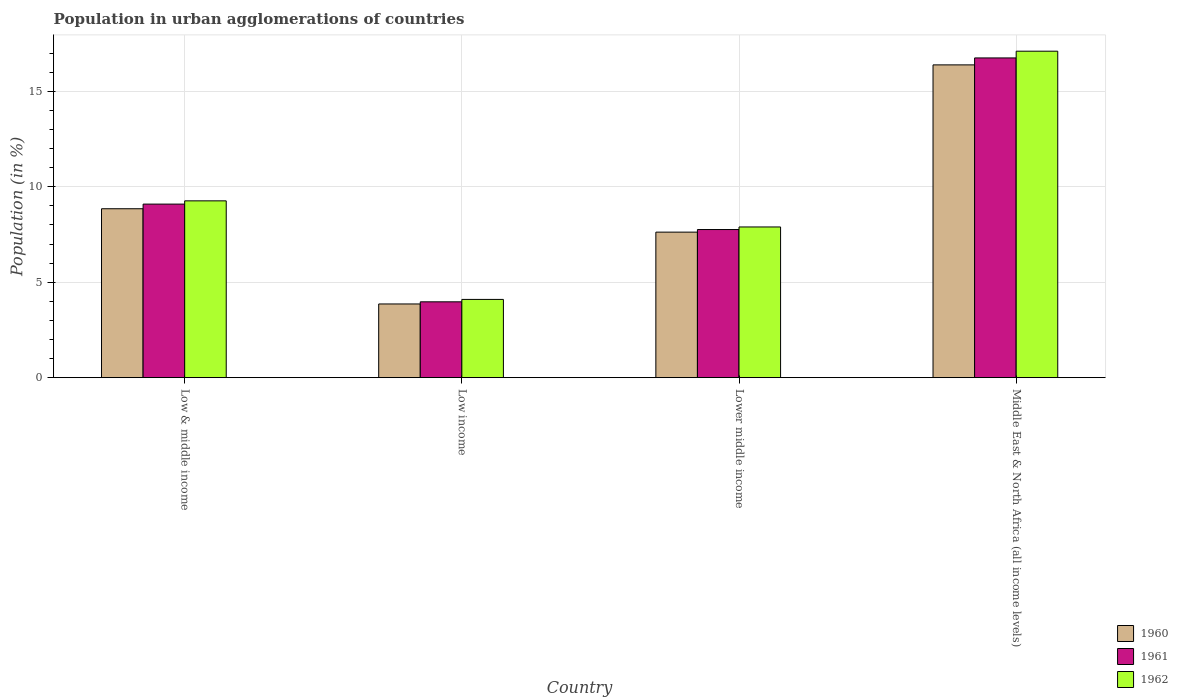How many groups of bars are there?
Your answer should be compact. 4. Are the number of bars on each tick of the X-axis equal?
Make the answer very short. Yes. How many bars are there on the 4th tick from the right?
Your answer should be very brief. 3. What is the label of the 1st group of bars from the left?
Give a very brief answer. Low & middle income. What is the percentage of population in urban agglomerations in 1961 in Low & middle income?
Your response must be concise. 9.09. Across all countries, what is the maximum percentage of population in urban agglomerations in 1960?
Ensure brevity in your answer.  16.39. Across all countries, what is the minimum percentage of population in urban agglomerations in 1960?
Ensure brevity in your answer.  3.86. In which country was the percentage of population in urban agglomerations in 1961 maximum?
Your answer should be very brief. Middle East & North Africa (all income levels). What is the total percentage of population in urban agglomerations in 1961 in the graph?
Your answer should be compact. 37.58. What is the difference between the percentage of population in urban agglomerations in 1961 in Low income and that in Lower middle income?
Your answer should be compact. -3.79. What is the difference between the percentage of population in urban agglomerations in 1962 in Lower middle income and the percentage of population in urban agglomerations in 1961 in Low income?
Make the answer very short. 3.92. What is the average percentage of population in urban agglomerations in 1962 per country?
Make the answer very short. 9.59. What is the difference between the percentage of population in urban agglomerations of/in 1960 and percentage of population in urban agglomerations of/in 1961 in Low income?
Provide a short and direct response. -0.11. In how many countries, is the percentage of population in urban agglomerations in 1962 greater than 16 %?
Offer a very short reply. 1. What is the ratio of the percentage of population in urban agglomerations in 1960 in Low & middle income to that in Lower middle income?
Offer a very short reply. 1.16. Is the percentage of population in urban agglomerations in 1961 in Low income less than that in Lower middle income?
Provide a succinct answer. Yes. What is the difference between the highest and the second highest percentage of population in urban agglomerations in 1962?
Make the answer very short. 7.84. What is the difference between the highest and the lowest percentage of population in urban agglomerations in 1961?
Your answer should be very brief. 12.78. Is the sum of the percentage of population in urban agglomerations in 1961 in Low & middle income and Middle East & North Africa (all income levels) greater than the maximum percentage of population in urban agglomerations in 1962 across all countries?
Keep it short and to the point. Yes. Is it the case that in every country, the sum of the percentage of population in urban agglomerations in 1960 and percentage of population in urban agglomerations in 1962 is greater than the percentage of population in urban agglomerations in 1961?
Ensure brevity in your answer.  Yes. How many bars are there?
Offer a very short reply. 12. Are all the bars in the graph horizontal?
Keep it short and to the point. No. How many countries are there in the graph?
Make the answer very short. 4. What is the difference between two consecutive major ticks on the Y-axis?
Ensure brevity in your answer.  5. Are the values on the major ticks of Y-axis written in scientific E-notation?
Give a very brief answer. No. How are the legend labels stacked?
Ensure brevity in your answer.  Vertical. What is the title of the graph?
Give a very brief answer. Population in urban agglomerations of countries. What is the label or title of the Y-axis?
Offer a very short reply. Population (in %). What is the Population (in %) of 1960 in Low & middle income?
Make the answer very short. 8.85. What is the Population (in %) of 1961 in Low & middle income?
Provide a succinct answer. 9.09. What is the Population (in %) of 1962 in Low & middle income?
Offer a terse response. 9.27. What is the Population (in %) in 1960 in Low income?
Offer a terse response. 3.86. What is the Population (in %) in 1961 in Low income?
Provide a succinct answer. 3.97. What is the Population (in %) in 1962 in Low income?
Make the answer very short. 4.1. What is the Population (in %) in 1960 in Lower middle income?
Offer a terse response. 7.63. What is the Population (in %) in 1961 in Lower middle income?
Keep it short and to the point. 7.76. What is the Population (in %) of 1962 in Lower middle income?
Your answer should be compact. 7.9. What is the Population (in %) in 1960 in Middle East & North Africa (all income levels)?
Your response must be concise. 16.39. What is the Population (in %) in 1961 in Middle East & North Africa (all income levels)?
Offer a terse response. 16.75. What is the Population (in %) in 1962 in Middle East & North Africa (all income levels)?
Your response must be concise. 17.11. Across all countries, what is the maximum Population (in %) of 1960?
Ensure brevity in your answer.  16.39. Across all countries, what is the maximum Population (in %) of 1961?
Your response must be concise. 16.75. Across all countries, what is the maximum Population (in %) of 1962?
Provide a short and direct response. 17.11. Across all countries, what is the minimum Population (in %) of 1960?
Your response must be concise. 3.86. Across all countries, what is the minimum Population (in %) of 1961?
Provide a succinct answer. 3.97. Across all countries, what is the minimum Population (in %) of 1962?
Ensure brevity in your answer.  4.1. What is the total Population (in %) of 1960 in the graph?
Your answer should be very brief. 36.73. What is the total Population (in %) of 1961 in the graph?
Give a very brief answer. 37.58. What is the total Population (in %) of 1962 in the graph?
Make the answer very short. 38.37. What is the difference between the Population (in %) in 1960 in Low & middle income and that in Low income?
Offer a very short reply. 4.99. What is the difference between the Population (in %) in 1961 in Low & middle income and that in Low income?
Make the answer very short. 5.12. What is the difference between the Population (in %) of 1962 in Low & middle income and that in Low income?
Offer a terse response. 5.16. What is the difference between the Population (in %) of 1960 in Low & middle income and that in Lower middle income?
Your response must be concise. 1.23. What is the difference between the Population (in %) of 1961 in Low & middle income and that in Lower middle income?
Keep it short and to the point. 1.33. What is the difference between the Population (in %) in 1962 in Low & middle income and that in Lower middle income?
Keep it short and to the point. 1.37. What is the difference between the Population (in %) in 1960 in Low & middle income and that in Middle East & North Africa (all income levels)?
Provide a succinct answer. -7.54. What is the difference between the Population (in %) of 1961 in Low & middle income and that in Middle East & North Africa (all income levels)?
Give a very brief answer. -7.66. What is the difference between the Population (in %) of 1962 in Low & middle income and that in Middle East & North Africa (all income levels)?
Make the answer very short. -7.84. What is the difference between the Population (in %) in 1960 in Low income and that in Lower middle income?
Ensure brevity in your answer.  -3.76. What is the difference between the Population (in %) of 1961 in Low income and that in Lower middle income?
Make the answer very short. -3.79. What is the difference between the Population (in %) of 1962 in Low income and that in Lower middle income?
Offer a very short reply. -3.8. What is the difference between the Population (in %) in 1960 in Low income and that in Middle East & North Africa (all income levels)?
Your answer should be very brief. -12.53. What is the difference between the Population (in %) of 1961 in Low income and that in Middle East & North Africa (all income levels)?
Your answer should be compact. -12.78. What is the difference between the Population (in %) of 1962 in Low income and that in Middle East & North Africa (all income levels)?
Your response must be concise. -13.01. What is the difference between the Population (in %) of 1960 in Lower middle income and that in Middle East & North Africa (all income levels)?
Give a very brief answer. -8.76. What is the difference between the Population (in %) in 1961 in Lower middle income and that in Middle East & North Africa (all income levels)?
Provide a succinct answer. -8.99. What is the difference between the Population (in %) of 1962 in Lower middle income and that in Middle East & North Africa (all income levels)?
Provide a succinct answer. -9.21. What is the difference between the Population (in %) in 1960 in Low & middle income and the Population (in %) in 1961 in Low income?
Ensure brevity in your answer.  4.88. What is the difference between the Population (in %) of 1960 in Low & middle income and the Population (in %) of 1962 in Low income?
Give a very brief answer. 4.75. What is the difference between the Population (in %) of 1961 in Low & middle income and the Population (in %) of 1962 in Low income?
Offer a terse response. 4.99. What is the difference between the Population (in %) in 1960 in Low & middle income and the Population (in %) in 1961 in Lower middle income?
Your answer should be compact. 1.09. What is the difference between the Population (in %) in 1960 in Low & middle income and the Population (in %) in 1962 in Lower middle income?
Make the answer very short. 0.95. What is the difference between the Population (in %) of 1961 in Low & middle income and the Population (in %) of 1962 in Lower middle income?
Provide a short and direct response. 1.2. What is the difference between the Population (in %) of 1960 in Low & middle income and the Population (in %) of 1961 in Middle East & North Africa (all income levels)?
Your response must be concise. -7.9. What is the difference between the Population (in %) of 1960 in Low & middle income and the Population (in %) of 1962 in Middle East & North Africa (all income levels)?
Ensure brevity in your answer.  -8.26. What is the difference between the Population (in %) of 1961 in Low & middle income and the Population (in %) of 1962 in Middle East & North Africa (all income levels)?
Provide a succinct answer. -8.01. What is the difference between the Population (in %) of 1960 in Low income and the Population (in %) of 1961 in Lower middle income?
Give a very brief answer. -3.9. What is the difference between the Population (in %) of 1960 in Low income and the Population (in %) of 1962 in Lower middle income?
Your answer should be compact. -4.03. What is the difference between the Population (in %) of 1961 in Low income and the Population (in %) of 1962 in Lower middle income?
Your answer should be very brief. -3.92. What is the difference between the Population (in %) in 1960 in Low income and the Population (in %) in 1961 in Middle East & North Africa (all income levels)?
Offer a very short reply. -12.89. What is the difference between the Population (in %) of 1960 in Low income and the Population (in %) of 1962 in Middle East & North Africa (all income levels)?
Offer a very short reply. -13.24. What is the difference between the Population (in %) in 1961 in Low income and the Population (in %) in 1962 in Middle East & North Africa (all income levels)?
Your response must be concise. -13.13. What is the difference between the Population (in %) in 1960 in Lower middle income and the Population (in %) in 1961 in Middle East & North Africa (all income levels)?
Provide a succinct answer. -9.13. What is the difference between the Population (in %) in 1960 in Lower middle income and the Population (in %) in 1962 in Middle East & North Africa (all income levels)?
Your answer should be compact. -9.48. What is the difference between the Population (in %) of 1961 in Lower middle income and the Population (in %) of 1962 in Middle East & North Africa (all income levels)?
Provide a short and direct response. -9.35. What is the average Population (in %) in 1960 per country?
Provide a short and direct response. 9.18. What is the average Population (in %) of 1961 per country?
Keep it short and to the point. 9.4. What is the average Population (in %) in 1962 per country?
Give a very brief answer. 9.59. What is the difference between the Population (in %) in 1960 and Population (in %) in 1961 in Low & middle income?
Offer a very short reply. -0.24. What is the difference between the Population (in %) in 1960 and Population (in %) in 1962 in Low & middle income?
Your response must be concise. -0.41. What is the difference between the Population (in %) of 1961 and Population (in %) of 1962 in Low & middle income?
Provide a short and direct response. -0.17. What is the difference between the Population (in %) of 1960 and Population (in %) of 1961 in Low income?
Offer a very short reply. -0.11. What is the difference between the Population (in %) in 1960 and Population (in %) in 1962 in Low income?
Offer a very short reply. -0.24. What is the difference between the Population (in %) of 1961 and Population (in %) of 1962 in Low income?
Give a very brief answer. -0.13. What is the difference between the Population (in %) of 1960 and Population (in %) of 1961 in Lower middle income?
Your answer should be compact. -0.14. What is the difference between the Population (in %) of 1960 and Population (in %) of 1962 in Lower middle income?
Offer a very short reply. -0.27. What is the difference between the Population (in %) in 1961 and Population (in %) in 1962 in Lower middle income?
Make the answer very short. -0.13. What is the difference between the Population (in %) in 1960 and Population (in %) in 1961 in Middle East & North Africa (all income levels)?
Give a very brief answer. -0.36. What is the difference between the Population (in %) of 1960 and Population (in %) of 1962 in Middle East & North Africa (all income levels)?
Make the answer very short. -0.72. What is the difference between the Population (in %) in 1961 and Population (in %) in 1962 in Middle East & North Africa (all income levels)?
Keep it short and to the point. -0.35. What is the ratio of the Population (in %) of 1960 in Low & middle income to that in Low income?
Make the answer very short. 2.29. What is the ratio of the Population (in %) of 1961 in Low & middle income to that in Low income?
Offer a terse response. 2.29. What is the ratio of the Population (in %) of 1962 in Low & middle income to that in Low income?
Keep it short and to the point. 2.26. What is the ratio of the Population (in %) in 1960 in Low & middle income to that in Lower middle income?
Your response must be concise. 1.16. What is the ratio of the Population (in %) of 1961 in Low & middle income to that in Lower middle income?
Keep it short and to the point. 1.17. What is the ratio of the Population (in %) of 1962 in Low & middle income to that in Lower middle income?
Give a very brief answer. 1.17. What is the ratio of the Population (in %) in 1960 in Low & middle income to that in Middle East & North Africa (all income levels)?
Your answer should be compact. 0.54. What is the ratio of the Population (in %) in 1961 in Low & middle income to that in Middle East & North Africa (all income levels)?
Keep it short and to the point. 0.54. What is the ratio of the Population (in %) in 1962 in Low & middle income to that in Middle East & North Africa (all income levels)?
Offer a terse response. 0.54. What is the ratio of the Population (in %) of 1960 in Low income to that in Lower middle income?
Your answer should be compact. 0.51. What is the ratio of the Population (in %) of 1961 in Low income to that in Lower middle income?
Your response must be concise. 0.51. What is the ratio of the Population (in %) of 1962 in Low income to that in Lower middle income?
Give a very brief answer. 0.52. What is the ratio of the Population (in %) in 1960 in Low income to that in Middle East & North Africa (all income levels)?
Your answer should be compact. 0.24. What is the ratio of the Population (in %) in 1961 in Low income to that in Middle East & North Africa (all income levels)?
Keep it short and to the point. 0.24. What is the ratio of the Population (in %) of 1962 in Low income to that in Middle East & North Africa (all income levels)?
Your answer should be compact. 0.24. What is the ratio of the Population (in %) in 1960 in Lower middle income to that in Middle East & North Africa (all income levels)?
Offer a very short reply. 0.47. What is the ratio of the Population (in %) in 1961 in Lower middle income to that in Middle East & North Africa (all income levels)?
Offer a very short reply. 0.46. What is the ratio of the Population (in %) in 1962 in Lower middle income to that in Middle East & North Africa (all income levels)?
Your answer should be very brief. 0.46. What is the difference between the highest and the second highest Population (in %) of 1960?
Make the answer very short. 7.54. What is the difference between the highest and the second highest Population (in %) in 1961?
Ensure brevity in your answer.  7.66. What is the difference between the highest and the second highest Population (in %) of 1962?
Provide a short and direct response. 7.84. What is the difference between the highest and the lowest Population (in %) in 1960?
Keep it short and to the point. 12.53. What is the difference between the highest and the lowest Population (in %) of 1961?
Your answer should be compact. 12.78. What is the difference between the highest and the lowest Population (in %) of 1962?
Offer a terse response. 13.01. 